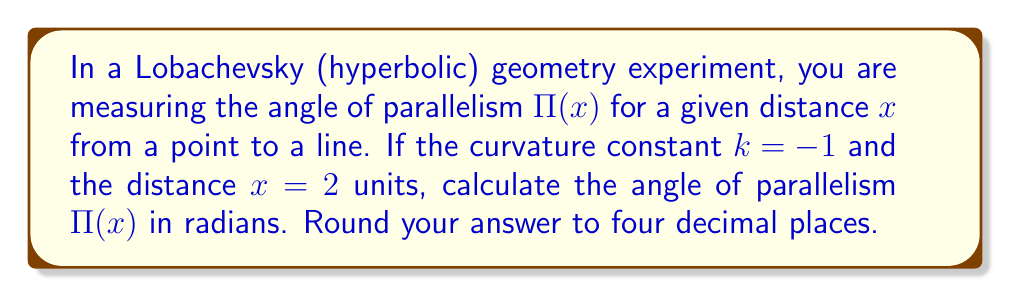Solve this math problem. To solve this problem, we'll follow these steps:

1. Recall the formula for the angle of parallelism in Lobachevsky geometry:

   $$\Pi(x) = 2 \arctan(e^{-kx})$$

   Where k is the curvature constant and x is the distance.

2. We are given:
   k = -1
   x = 2 units

3. Substitute these values into the formula:

   $$\Pi(2) = 2 \arctan(e^{-(-1)(2)})$$

4. Simplify the exponent:

   $$\Pi(2) = 2 \arctan(e^2)$$

5. Calculate e^2:

   $$e^2 \approx 7.3890561$$

6. Apply the arctangent function:

   $$\Pi(2) = 2 \arctan(7.3890561)$$

7. Calculate the arctangent:

   $$\arctan(7.3890561) \approx 1.4366724$$

8. Multiply by 2:

   $$\Pi(2) = 2(1.4366724) \approx 2.8733448$$

9. Round to four decimal places:

   $$\Pi(2) \approx 2.8733$$

This result represents the angle of parallelism in radians for the given conditions in Lobachevsky geometry.
Answer: $2.8733$ radians 